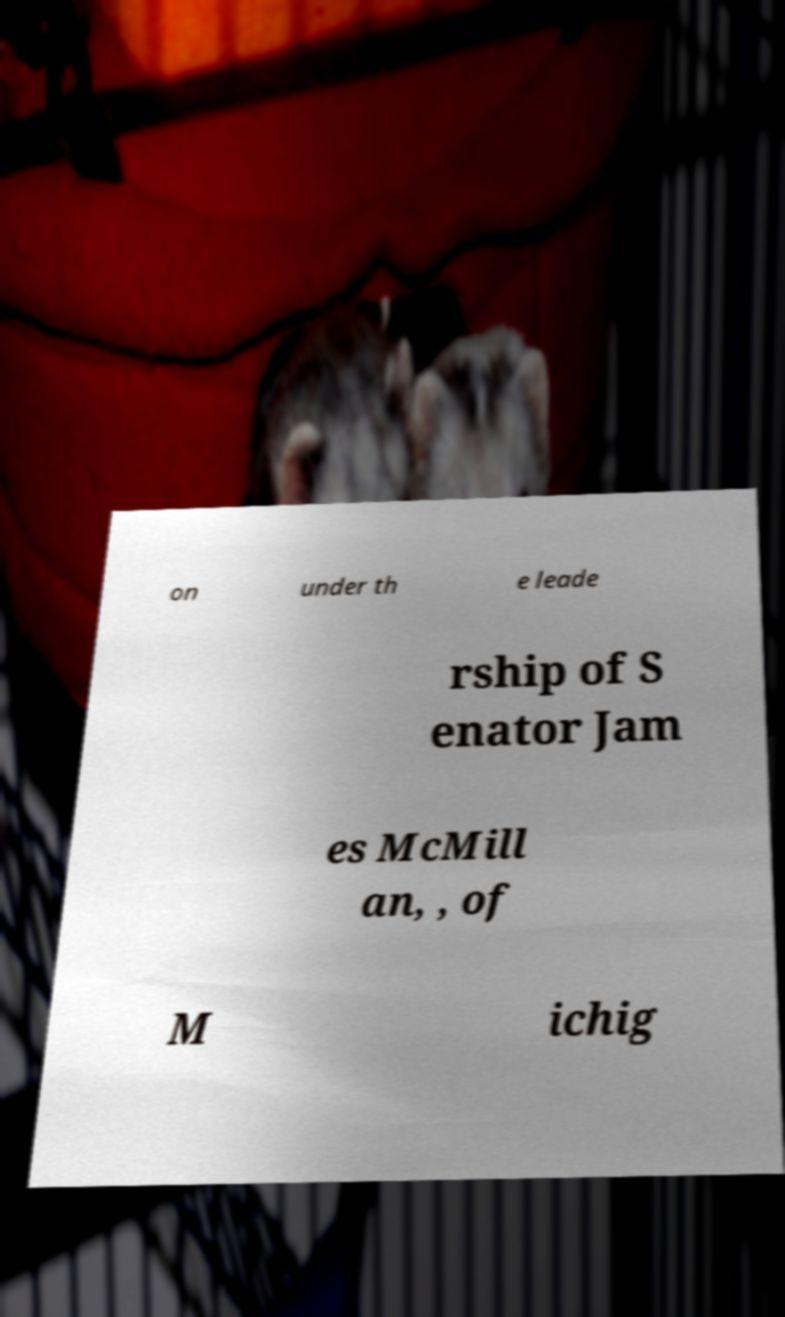Please identify and transcribe the text found in this image. on under th e leade rship of S enator Jam es McMill an, , of M ichig 